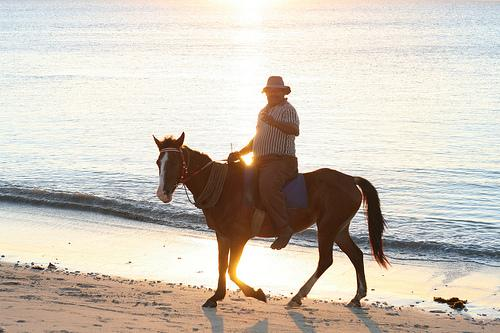What kind of surface is the horse walking on, and what kind of water body is it near? The horse walks on wet sand of the beach, close to the clear blue water of the ocean. Count the hooves on the horse and describe their color. There are three visible black hooves on the horse. What kind of hat and clothing is the man wearing? The man is wearing a grey hat, striped shirt, black and white shirt, and grey pants. How many ears does the horse have, and what is their color? The horse has two brown ears. What type of weather is depicted in the image? The weather appears to be sunny with white clouds in the blue sky. Describe the scene captured in the image. A man is riding a brown and white horse on a beach, with the ocean in the background and a sunny sky above. What is the color of the saddle the man is sitting on? The man is sitting on a blue saddle. Identify the type of animal and its primary color in the image. A brown horse with white markings on its head is the main animal. Are there any distinct features on the horse's head? Yes, the horse has a white line on the front of its face and brown ears on its head. Describe the position of the sun in relation to the water. The sun is setting, and its reflection creates sunlight in the water. How many legs does the horse have? Four Explain the role of the sun in the image. The sun is setting and shining on the water. Where is the man positioned on the horse? On the back of the horse Describe the appearance of the horse in the image. Brown and white horse with a brown tail, brown legs, and a brown and white face. Identify the celestial object that creates reflections in the water. Sun Is the horse wearing a blue hat at X:254 Y:73? The image has a brown hat on the man's head, not a blue hat on the horse. Describe the surface the horse is walking on. Wet sand on the beach What type of body of water is visible in the image? Ocean Do you see an orange sun at X:235 Y:142? The sun is mentioned as setting, but its color is not specified. The instruction assumes it's orange, which could be misleading. Write a poetic caption inspired by the image. A horse and a rider, on sun-kissed sand, the ocean whispers, as they unite with the land. Is the horse's tail long or short? Long What is the main activity taking place in the image? A man riding a horse on the beach Identify the facial feature that is brown on the horse. Brown ears Determine the hat color worn by the man. Brown (Grey can also be considered correct) Is there a purple cloud in the sky at X:128 Y:13? The image only contains white clouds in the blue sky, not any purple ones. Is the horse standing on green grass at X:155 Y:117? The horse is walking on a beach with wet sand, not on green grass. Can you see a green saddle on the horse at X:240 Y:70? The image shows a man sitting on a blue saddle, not a green one. What material is the saddle made out of? Blue Which of the following is depicted in the image? A) man riding a motorcycle B) man riding a horse on the beach C) woman riding a bike in a park Man riding a horse on the beach Can you spot a pink stripe on the man's shirt at X:248 Y:105? The man is wearing a striped shirt, but it is not pink. The image has a black and white striped shirt. Provide a description of the sky. Blue sky with white clouds What is the most noticeable feature on the horse's head? White marking What type of shirt is the man wearing? Black and white striped shirt What type of animal forms the primary interaction in the scene? A horse Locate the area where the sunlight is reflected. In the water 